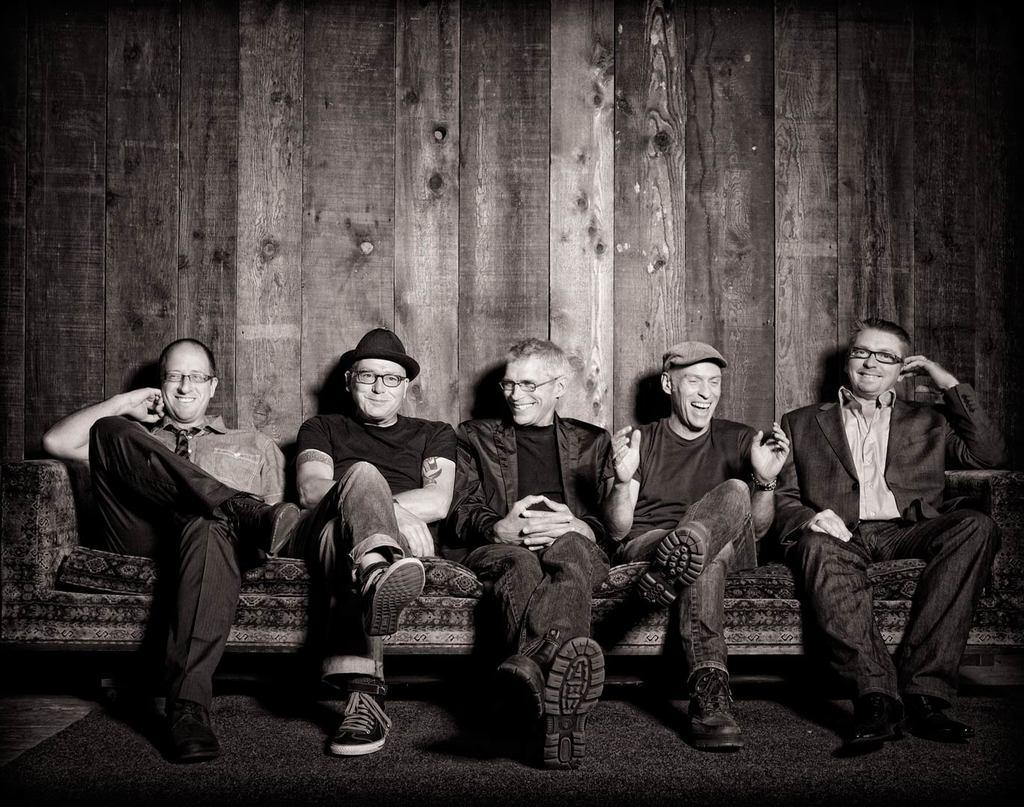How many people are in the image? There are five persons in the image. What are the persons doing in the image? The persons are sitting on a sofa. What type of wall can be seen in the background of the image? There is a wooden wall in the background of the image. Where was the image taken? The image was taken in a hall. What type of tree can be seen in the image? There is no tree present in the image. Can you tell me what the persons are arguing about in the image? There is no argument depicted in the image; the persons are simply sitting on a sofa. 